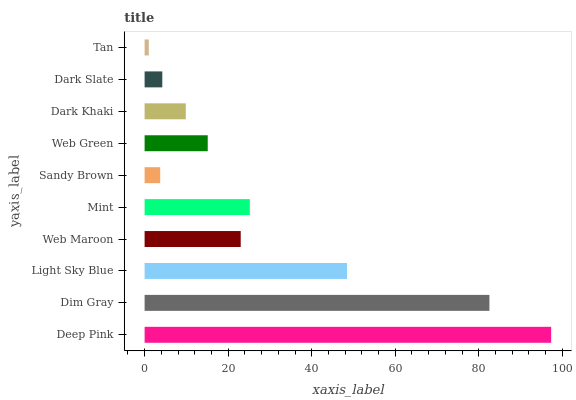Is Tan the minimum?
Answer yes or no. Yes. Is Deep Pink the maximum?
Answer yes or no. Yes. Is Dim Gray the minimum?
Answer yes or no. No. Is Dim Gray the maximum?
Answer yes or no. No. Is Deep Pink greater than Dim Gray?
Answer yes or no. Yes. Is Dim Gray less than Deep Pink?
Answer yes or no. Yes. Is Dim Gray greater than Deep Pink?
Answer yes or no. No. Is Deep Pink less than Dim Gray?
Answer yes or no. No. Is Web Maroon the high median?
Answer yes or no. Yes. Is Web Green the low median?
Answer yes or no. Yes. Is Dim Gray the high median?
Answer yes or no. No. Is Dark Khaki the low median?
Answer yes or no. No. 